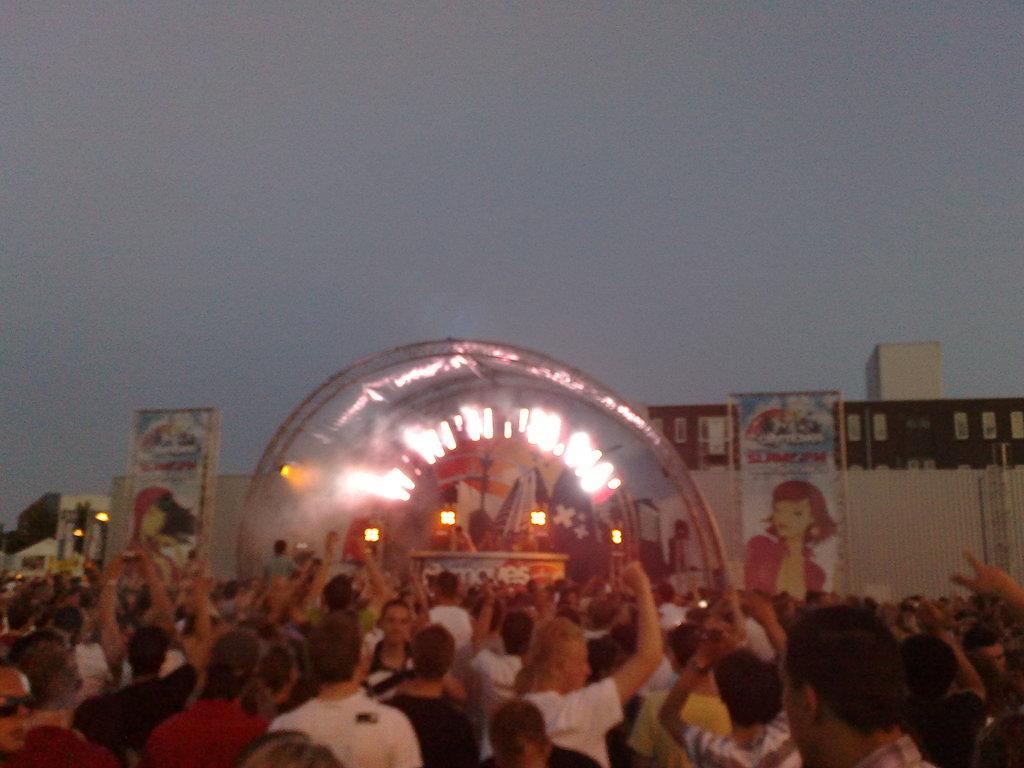Please provide a concise description of this image. In this image we can see people dancing, there is a shed with lights, also we can see two posts with persons image and some text written on it, there are some buildings and we can see the sky. 